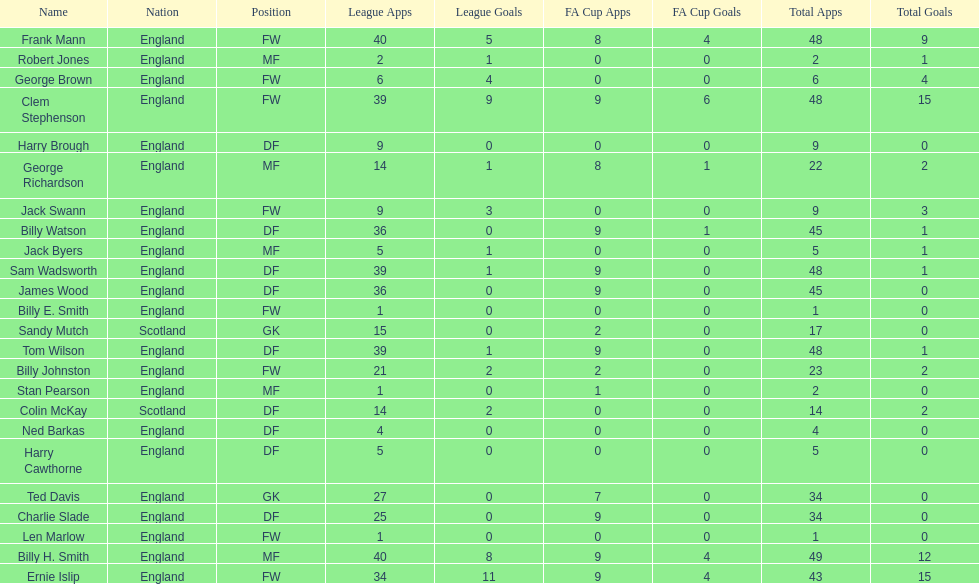How many players are fws? 8. 